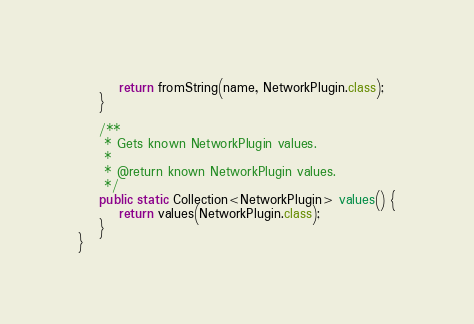<code> <loc_0><loc_0><loc_500><loc_500><_Java_>        return fromString(name, NetworkPlugin.class);
    }

    /**
     * Gets known NetworkPlugin values.
     *
     * @return known NetworkPlugin values.
     */
    public static Collection<NetworkPlugin> values() {
        return values(NetworkPlugin.class);
    }
}
</code> 